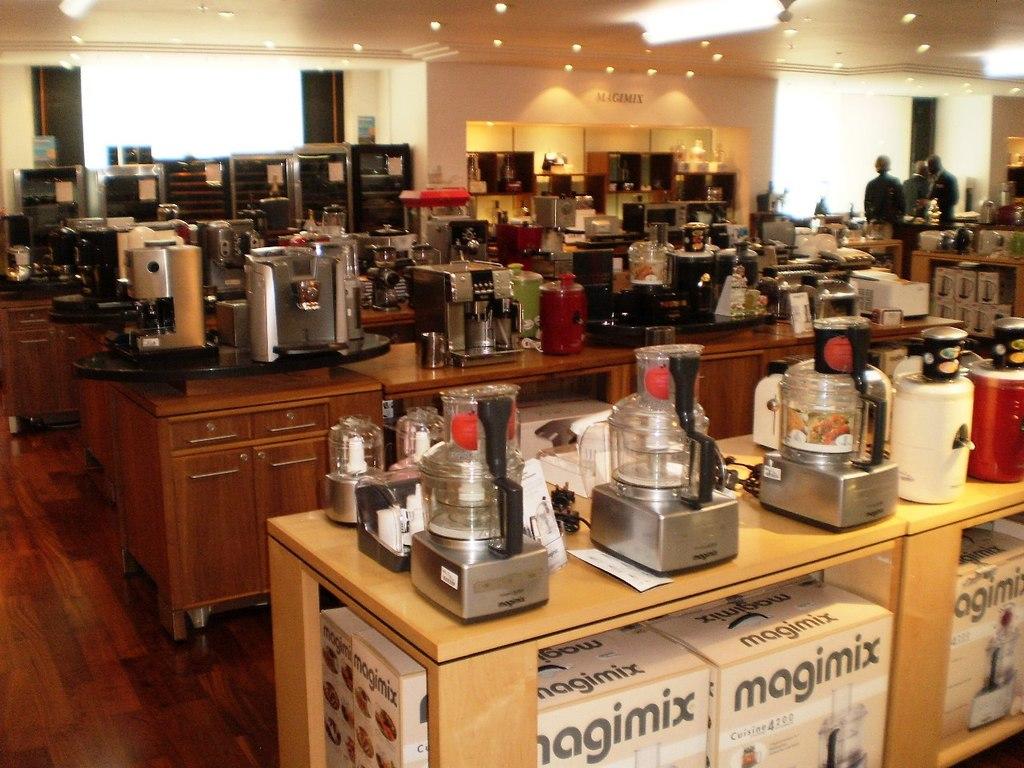What is the brand of the appliances on the nearby table?
Provide a succinct answer. Magimix. What brand is the mixer?
Give a very brief answer. Magimix. 